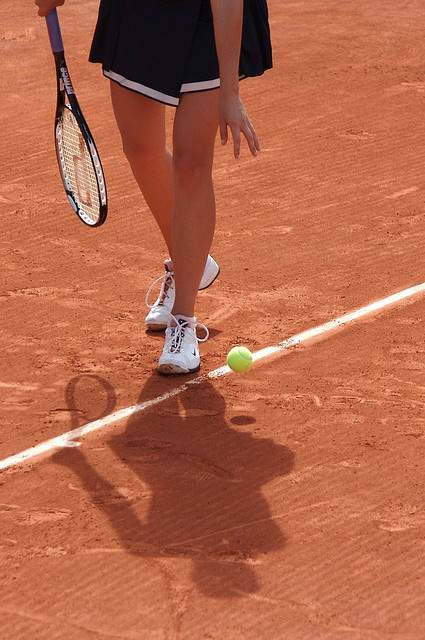Describe the objects in this image and their specific colors. I can see people in red, black, brown, and maroon tones, tennis racket in red, tan, black, brown, and ivory tones, and sports ball in red, olive, khaki, lightgreen, and lightyellow tones in this image. 